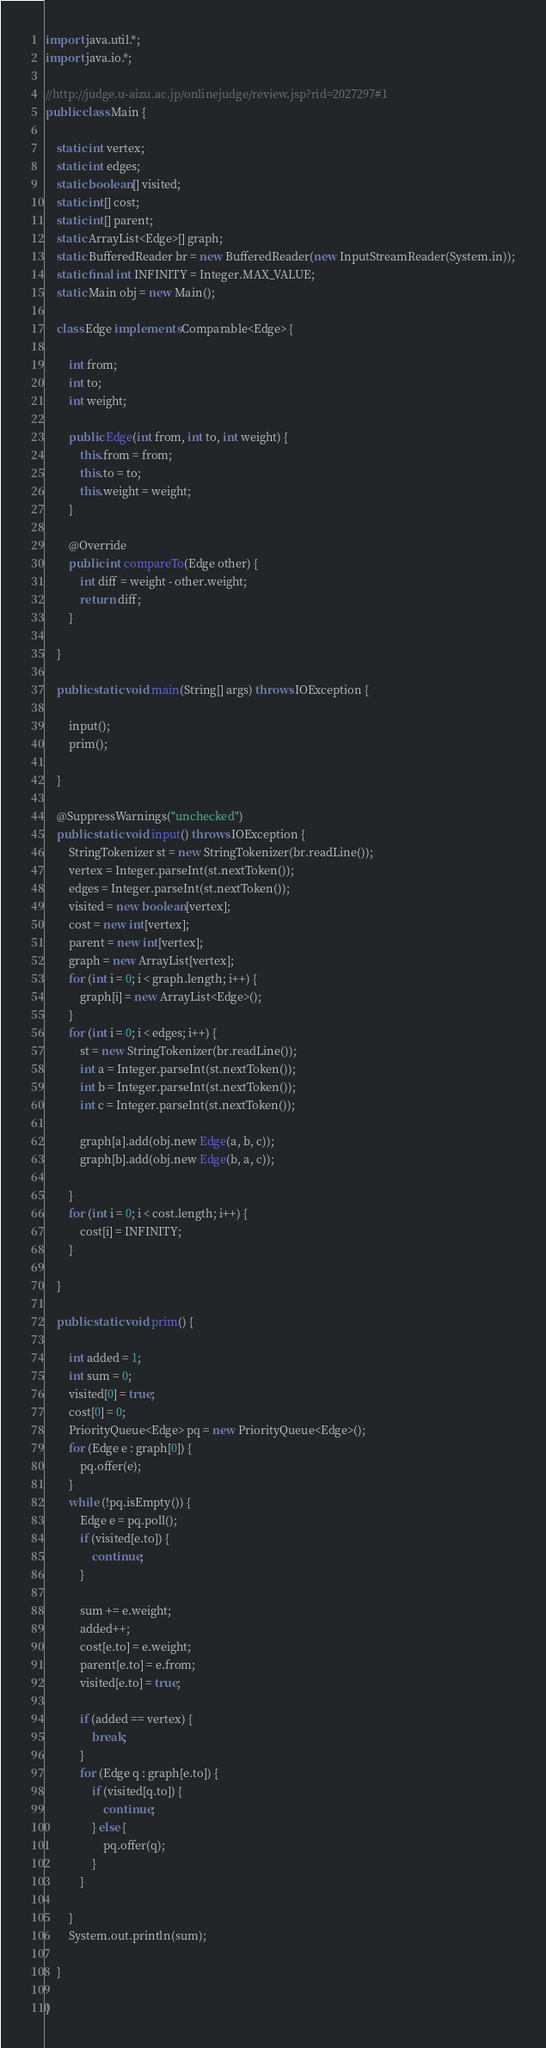Convert code to text. <code><loc_0><loc_0><loc_500><loc_500><_Java_>import java.util.*;
import java.io.*;

//http://judge.u-aizu.ac.jp/onlinejudge/review.jsp?rid=2027297#1
public class Main {

	static int vertex;
	static int edges;
	static boolean[] visited;
	static int[] cost;
	static int[] parent;
	static ArrayList<Edge>[] graph;
	static BufferedReader br = new BufferedReader(new InputStreamReader(System.in));
	static final int INFINITY = Integer.MAX_VALUE;
	static Main obj = new Main();

	class Edge implements Comparable<Edge> {

		int from;
		int to;
		int weight;

		public Edge(int from, int to, int weight) {
			this.from = from;
			this.to = to;
			this.weight = weight;
		}

		@Override
		public int compareTo(Edge other) {
			int diff = weight - other.weight;
			return diff;
		}

	}

	public static void main(String[] args) throws IOException {

		input();
		prim();

	}

	@SuppressWarnings("unchecked")
	public static void input() throws IOException {
		StringTokenizer st = new StringTokenizer(br.readLine());
		vertex = Integer.parseInt(st.nextToken());
		edges = Integer.parseInt(st.nextToken());
		visited = new boolean[vertex];
		cost = new int[vertex];
		parent = new int[vertex];
		graph = new ArrayList[vertex];
		for (int i = 0; i < graph.length; i++) {
			graph[i] = new ArrayList<Edge>();
		}
		for (int i = 0; i < edges; i++) {
			st = new StringTokenizer(br.readLine());
			int a = Integer.parseInt(st.nextToken());
			int b = Integer.parseInt(st.nextToken());
			int c = Integer.parseInt(st.nextToken());

			graph[a].add(obj.new Edge(a, b, c));
			graph[b].add(obj.new Edge(b, a, c));

		}
		for (int i = 0; i < cost.length; i++) {
			cost[i] = INFINITY;
		}

	}

	public static void prim() {

		int added = 1;
		int sum = 0;
		visited[0] = true;
		cost[0] = 0;
		PriorityQueue<Edge> pq = new PriorityQueue<Edge>();
		for (Edge e : graph[0]) {
			pq.offer(e);
		}
		while (!pq.isEmpty()) {
			Edge e = pq.poll();
			if (visited[e.to]) {
				continue;
			}

			sum += e.weight;
			added++;
			cost[e.to] = e.weight;
			parent[e.to] = e.from;
			visited[e.to] = true;

			if (added == vertex) {
				break;
			}
			for (Edge q : graph[e.to]) {
				if (visited[q.to]) {
					continue;
				} else {
					pq.offer(q);
				}
			}

		}
		System.out.println(sum);

	}

}</code> 